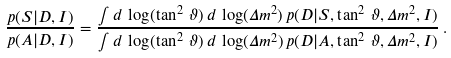<formula> <loc_0><loc_0><loc_500><loc_500>\frac { p ( S | D , I ) } { p ( A | D , I ) } = \frac { \int d \, \log ( \tan ^ { 2 } \, \vartheta ) \, d \, \log ( \Delta { m } ^ { 2 } ) \, p ( D | S , \tan ^ { 2 } \, \vartheta , \Delta { m } ^ { 2 } , I ) } { \int d \, \log ( \tan ^ { 2 } \, \vartheta ) \, d \, \log ( \Delta { m } ^ { 2 } ) \, p ( D | A , \tan ^ { 2 } \, \vartheta , \Delta { m } ^ { 2 } , I ) } \, .</formula> 